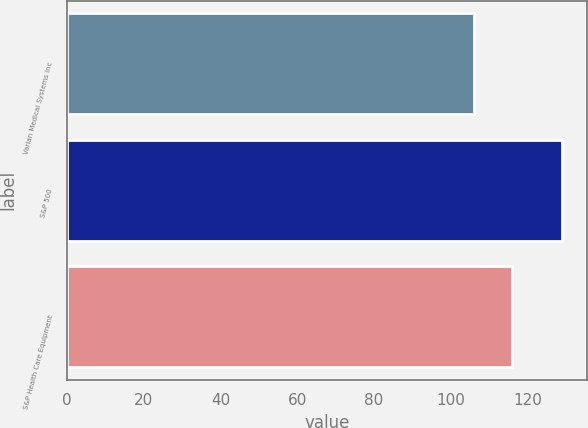Convert chart to OTSL. <chart><loc_0><loc_0><loc_500><loc_500><bar_chart><fcel>Varian Medical Systems Inc<fcel>S&P 500<fcel>S&P Health Care Equipment<nl><fcel>106.02<fcel>129.01<fcel>115.83<nl></chart> 